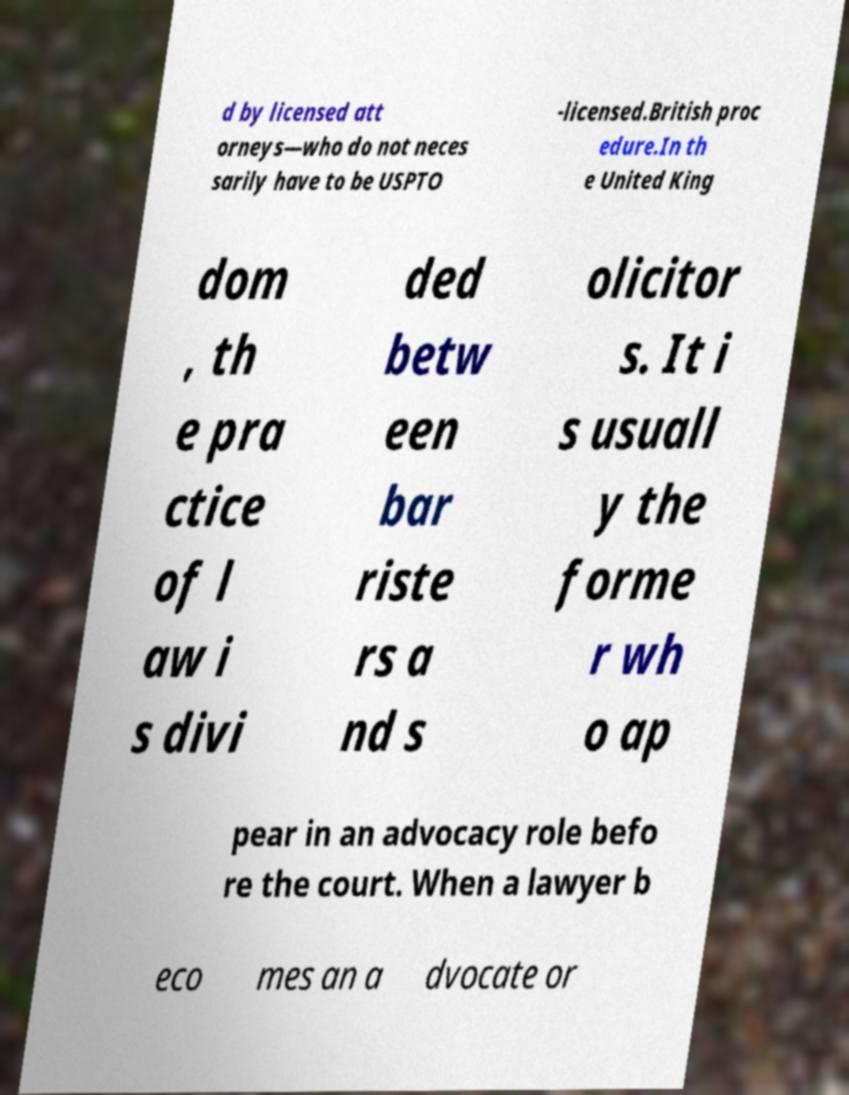For documentation purposes, I need the text within this image transcribed. Could you provide that? d by licensed att orneys—who do not neces sarily have to be USPTO -licensed.British proc edure.In th e United King dom , th e pra ctice of l aw i s divi ded betw een bar riste rs a nd s olicitor s. It i s usuall y the forme r wh o ap pear in an advocacy role befo re the court. When a lawyer b eco mes an a dvocate or 